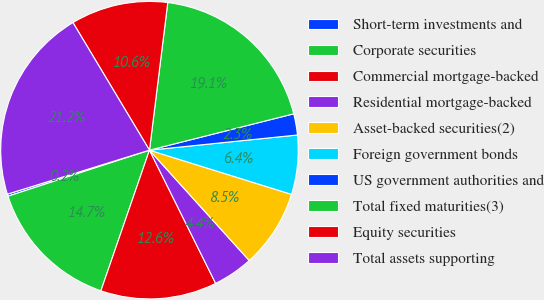Convert chart to OTSL. <chart><loc_0><loc_0><loc_500><loc_500><pie_chart><fcel>Short-term investments and<fcel>Corporate securities<fcel>Commercial mortgage-backed<fcel>Residential mortgage-backed<fcel>Asset-backed securities(2)<fcel>Foreign government bonds<fcel>US government authorities and<fcel>Total fixed maturities(3)<fcel>Equity securities<fcel>Total assets supporting<nl><fcel>0.23%<fcel>14.7%<fcel>12.63%<fcel>4.36%<fcel>8.5%<fcel>6.43%<fcel>2.3%<fcel>19.11%<fcel>10.56%<fcel>21.18%<nl></chart> 